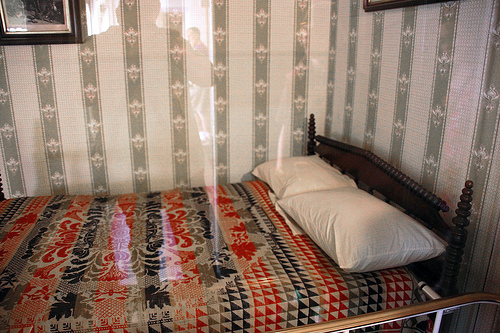Are there both pillows and pictures in the photo? Yes, the photo indeed features both pillows and pictures. You can notice the pillow resting comfortably on a bed with floral designs, and vintage decorative pictures hung on the wallpapered wall. 